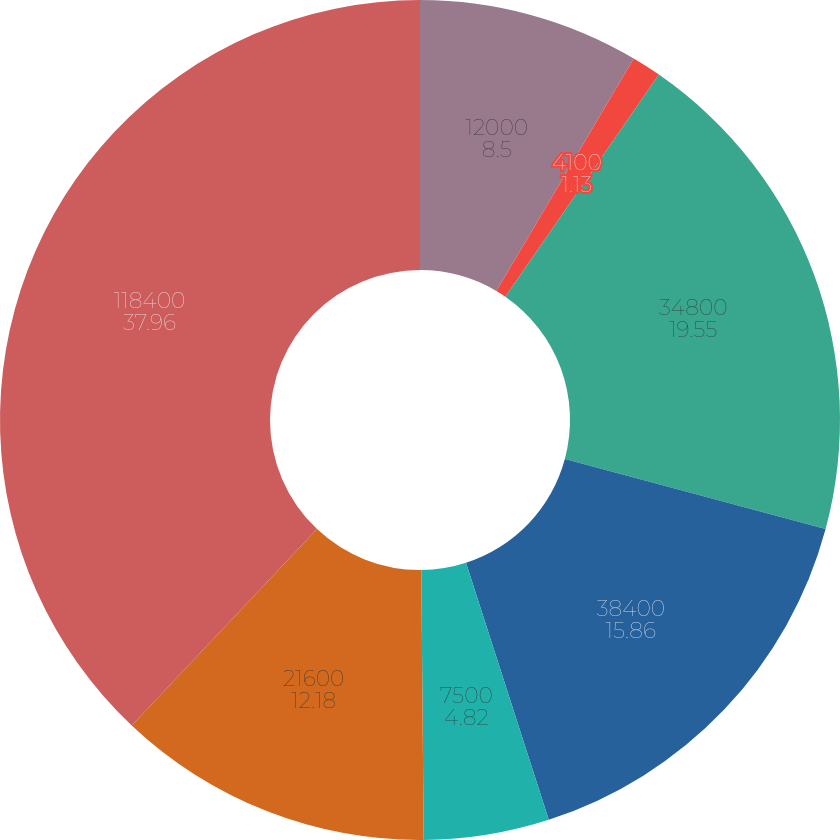Convert chart to OTSL. <chart><loc_0><loc_0><loc_500><loc_500><pie_chart><fcel>12000<fcel>4100<fcel>34800<fcel>38400<fcel>7500<fcel>21600<fcel>118400<nl><fcel>8.5%<fcel>1.13%<fcel>19.55%<fcel>15.86%<fcel>4.82%<fcel>12.18%<fcel>37.96%<nl></chart> 